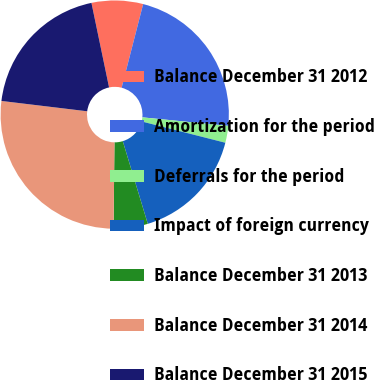Convert chart. <chart><loc_0><loc_0><loc_500><loc_500><pie_chart><fcel>Balance December 31 2012<fcel>Amortization for the period<fcel>Deferrals for the period<fcel>Impact of foreign currency<fcel>Balance December 31 2013<fcel>Balance December 31 2014<fcel>Balance December 31 2015<nl><fcel>7.28%<fcel>22.57%<fcel>2.39%<fcel>16.36%<fcel>4.84%<fcel>26.75%<fcel>19.82%<nl></chart> 